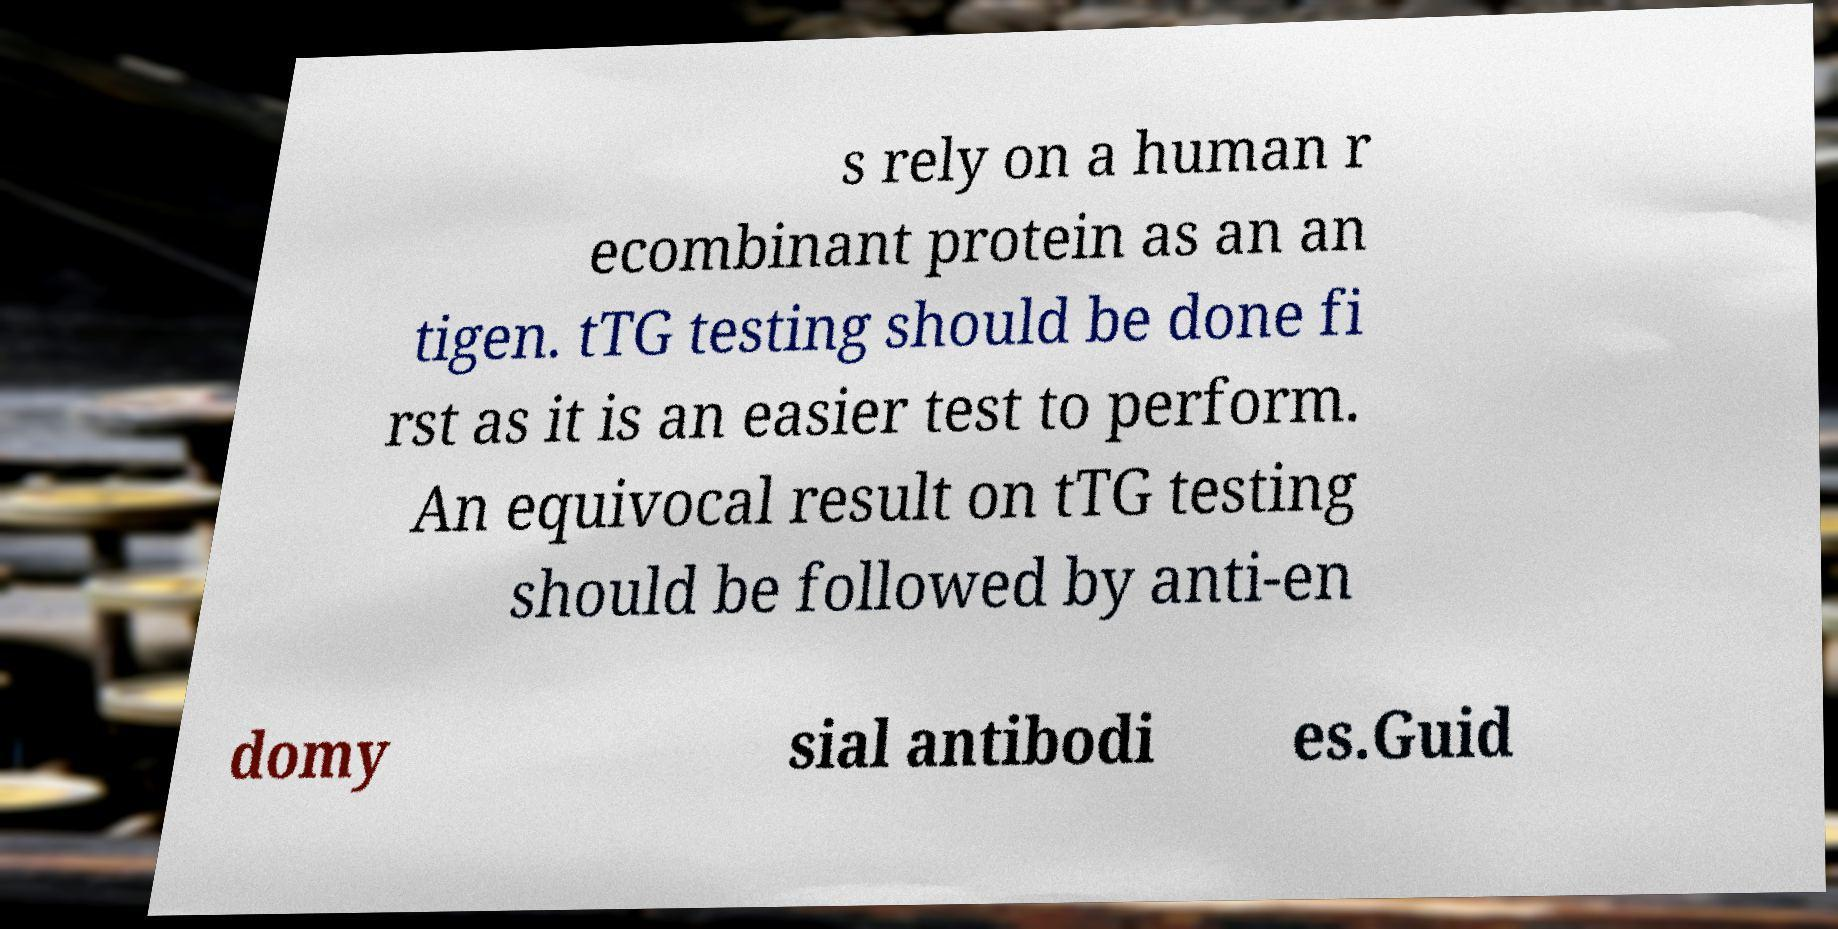Can you accurately transcribe the text from the provided image for me? s rely on a human r ecombinant protein as an an tigen. tTG testing should be done fi rst as it is an easier test to perform. An equivocal result on tTG testing should be followed by anti-en domy sial antibodi es.Guid 